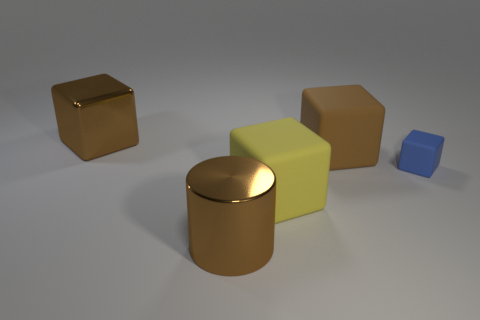How does the lighting affect the appearance of the objects in the scene? The lighting in the scene creates soft shadows and highlights the reflective nature of the shiny objects, giving them a three-dimensional appearance. It's subtle enough not to create harsh contrasts, maintaining a calm and balanced ambiance. 